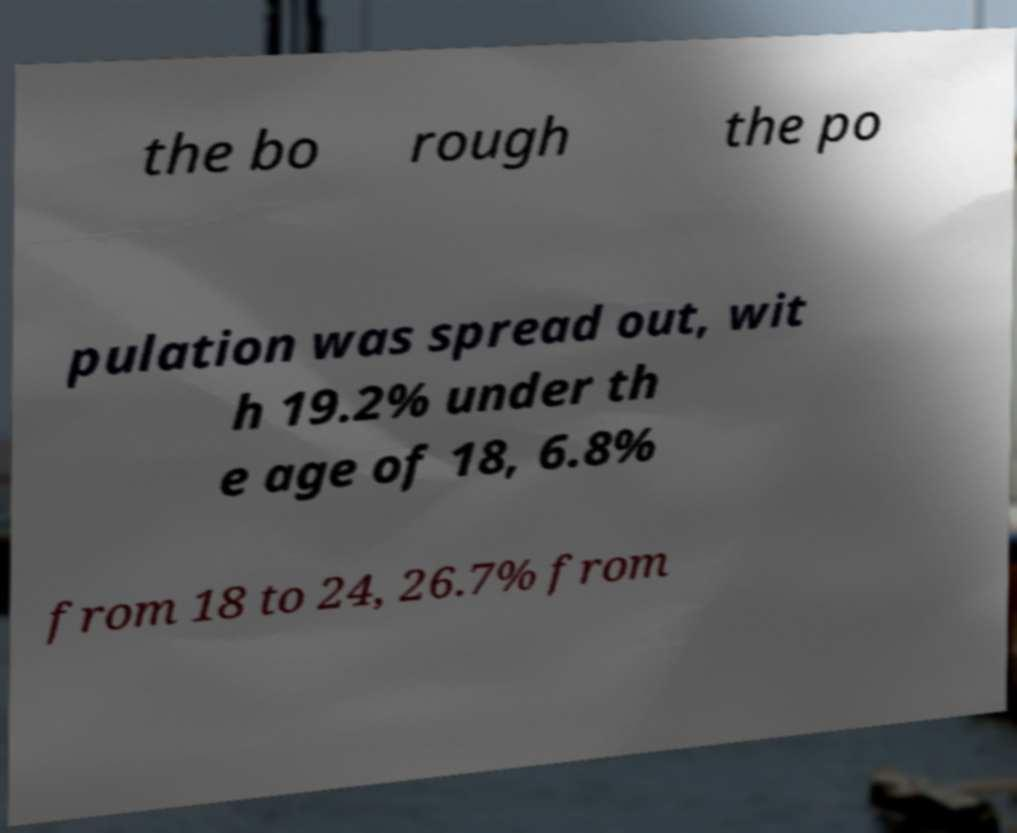Could you assist in decoding the text presented in this image and type it out clearly? the bo rough the po pulation was spread out, wit h 19.2% under th e age of 18, 6.8% from 18 to 24, 26.7% from 